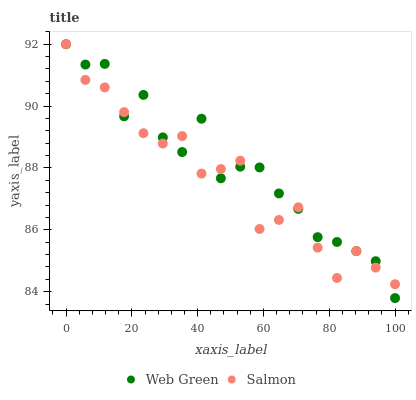Does Salmon have the minimum area under the curve?
Answer yes or no. Yes. Does Web Green have the maximum area under the curve?
Answer yes or no. Yes. Does Web Green have the minimum area under the curve?
Answer yes or no. No. Is Salmon the smoothest?
Answer yes or no. Yes. Is Web Green the roughest?
Answer yes or no. Yes. Is Web Green the smoothest?
Answer yes or no. No. Does Web Green have the lowest value?
Answer yes or no. Yes. Does Web Green have the highest value?
Answer yes or no. Yes. Does Web Green intersect Salmon?
Answer yes or no. Yes. Is Web Green less than Salmon?
Answer yes or no. No. Is Web Green greater than Salmon?
Answer yes or no. No. 